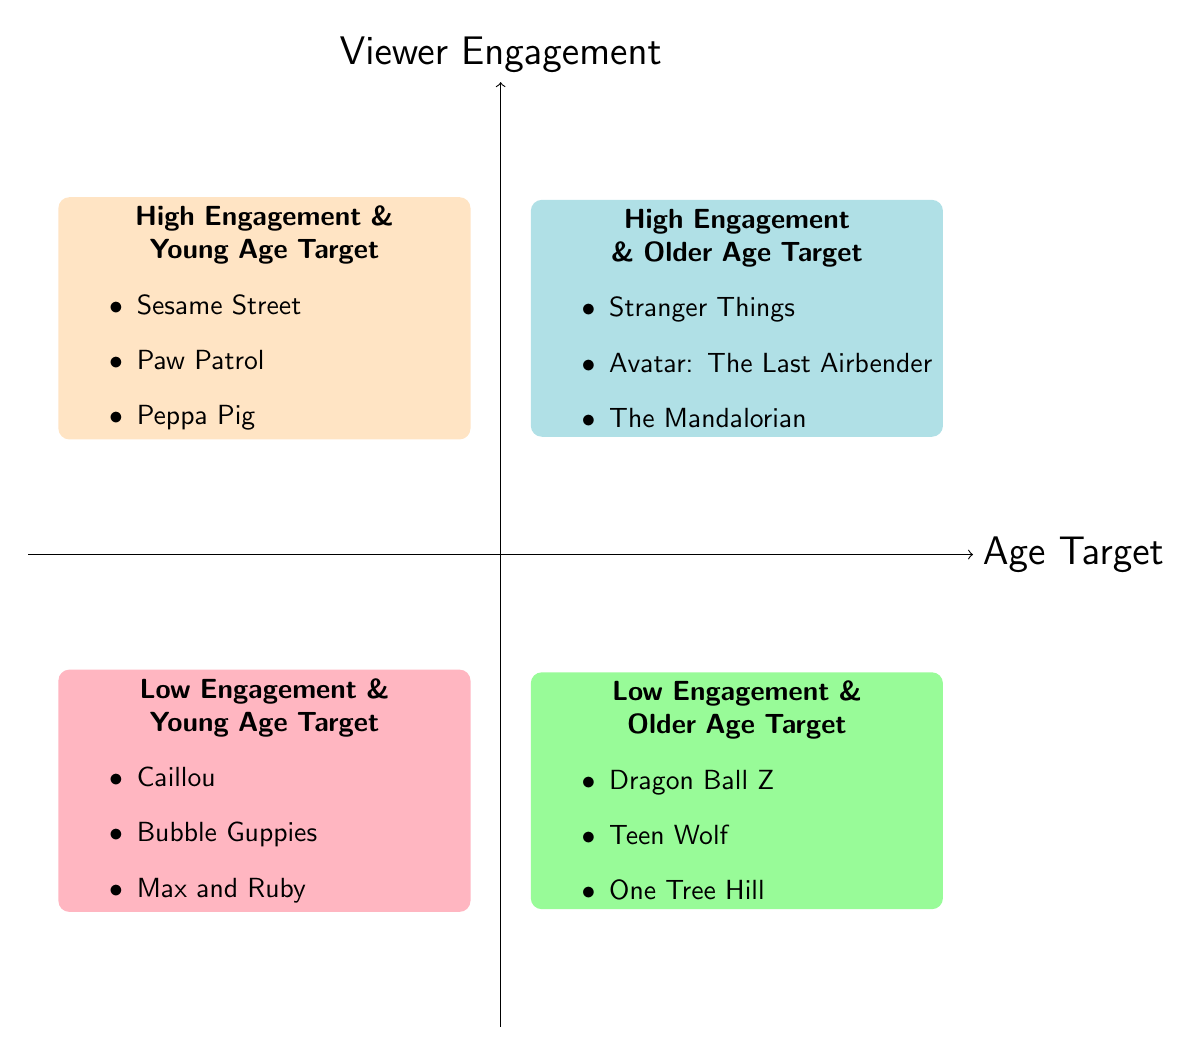What shows are in the High Engagement & Young Age Target quadrant? To find the shows, look for the quadrant titled "High Engagement & Young Age Target", which lists the shows as Sesame Street, Paw Patrol, and Peppa Pig.
Answer: Sesame Street, Paw Patrol, Peppa Pig How many shows are listed in the Low Engagement & Older Age Target quadrant? Count the shows listed under the "Low Engagement & Older Age Target" quadrant. There are three shows mentioned: Dragon Ball Z, Teen Wolf, and One Tree Hill.
Answer: 3 Which quadrant contains "Stranger Things"? Locate "Stranger Things" in the quadrants and see that it is part of the "High Engagement & Older Age Target" section.
Answer: High Engagement & Older Age Target Is "Caillou" listed under high or low engagement? Check the quadrant that contains "Caillou"; it is in the "Low Engagement & Young Age Target" quadrant, indicating low engagement.
Answer: Low engagement What is the relationship between shows with high engagement and young age target? All shows listed in the "High Engagement & Young Age Target" quadrant (Sesame Street, Paw Patrol, Peppa Pig) are designed for younger audiences and achieve high viewer engagement.
Answer: High engagement and young audiences Which quadrant has shows aimed at older audiences but with low engagement? Review the quadrants and find that the "Low Engagement & Older Age Target" quadrant contains shows aimed at older audiences but with low viewer engagement.
Answer: Low Engagement & Older Age Target What is the total number of quadrants in the chart? Count the distinct quadrants present in the diagram; there are a total of four quadrants in the chart.
Answer: 4 Which family-friendly show has the highest viewer engagement? Refer to the "High Engagement" labeled quadrants; "Stranger Things" would be mentioned, but it targets older audiences, while younger targets include shows listed in the High Engagement & Young Age Target quadrant. The highest could be context-defined, but among younger audiences, it's essential to clarify.
Answer: Context-dependent What shows are found in the Low Engagement & Young Age Target quadrant? Identify the shows listed in the "Low Engagement & Young Age Target" quadrant, which includes Caillou, Bubble Guppies, and Max and Ruby.
Answer: Caillou, Bubble Guppies, Max and Ruby 